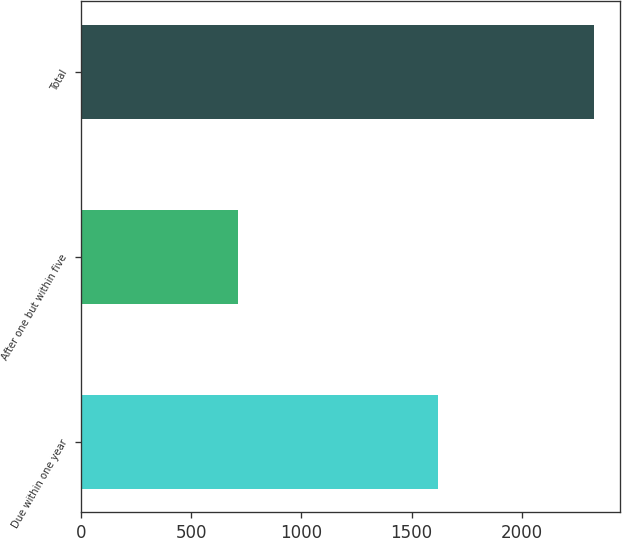Convert chart. <chart><loc_0><loc_0><loc_500><loc_500><bar_chart><fcel>Due within one year<fcel>After one but within five<fcel>Total<nl><fcel>1618<fcel>711<fcel>2329<nl></chart> 